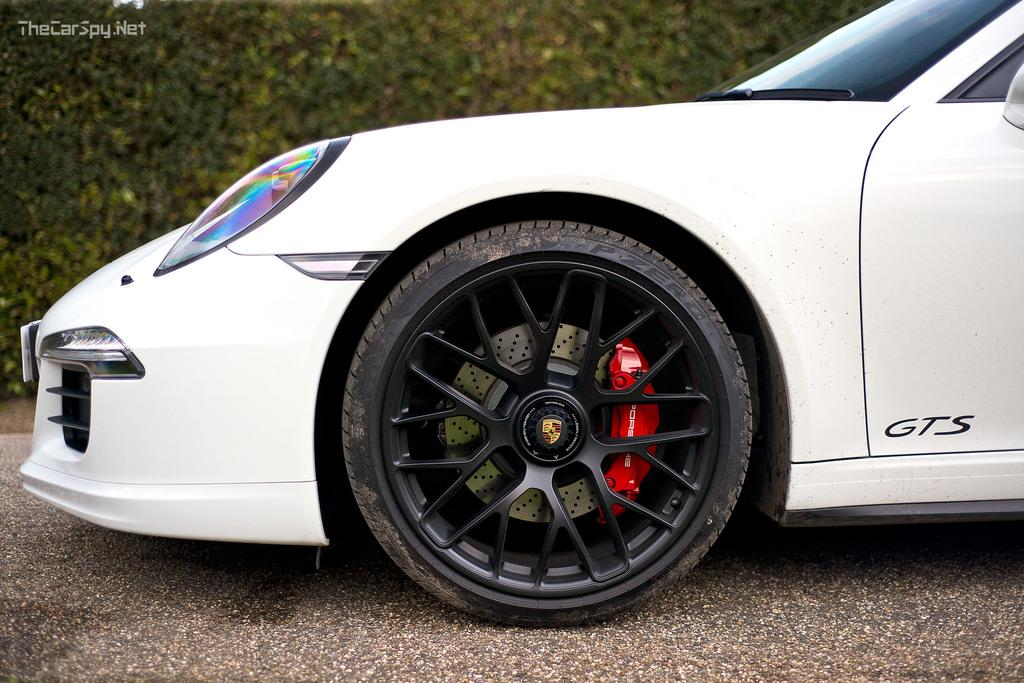What is the main subject of the image? The main subject of the image is a car. What feature of the car is mentioned in the facts? The car has a wheel. Are there any other objects or elements in the image besides the car? Yes, there are plants near the car. Can you see a kite flying in the image? No, there is no kite present in the image. Is there a body of water visible in the image? No, there is no body of water mentioned in the facts provided. 